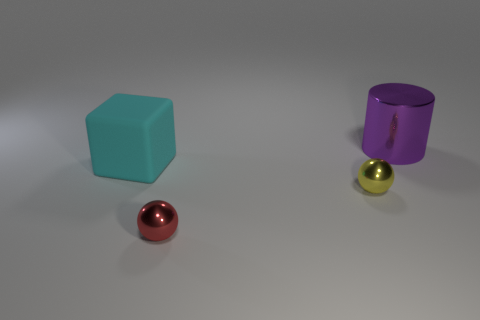The yellow ball that is the same material as the large cylinder is what size?
Keep it short and to the point. Small. What number of tiny yellow objects are the same shape as the large purple thing?
Provide a succinct answer. 0. How many objects are objects that are behind the red shiny sphere or small shiny balls that are behind the tiny red thing?
Make the answer very short. 3. What number of red spheres are on the right side of the big object to the left of the large purple cylinder?
Your response must be concise. 1. There is a thing behind the big cyan object; does it have the same shape as the tiny metallic object that is on the left side of the yellow thing?
Ensure brevity in your answer.  No. Are there any big blue objects made of the same material as the big cyan object?
Your answer should be compact. No. How many rubber objects are either yellow objects or tiny blue blocks?
Offer a very short reply. 0. What is the shape of the large thing to the left of the metal thing behind the big rubber cube?
Your answer should be very brief. Cube. Are there fewer large purple metal cylinders in front of the red shiny object than spheres?
Make the answer very short. Yes. There is a large purple metal thing; what shape is it?
Your response must be concise. Cylinder. 